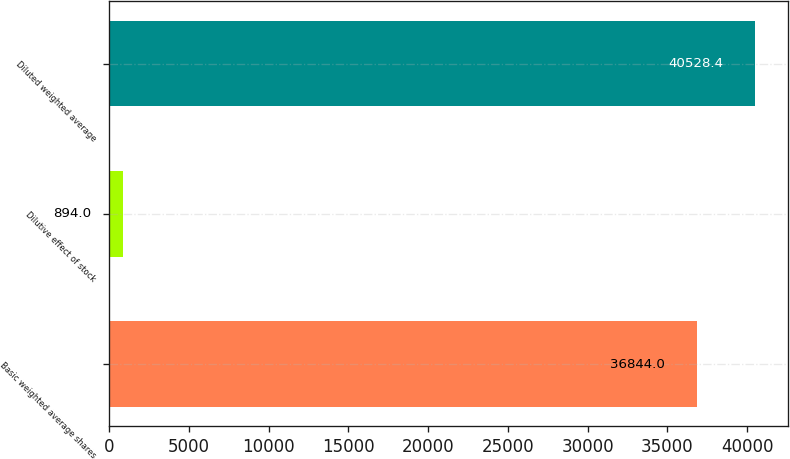<chart> <loc_0><loc_0><loc_500><loc_500><bar_chart><fcel>Basic weighted average shares<fcel>Dilutive effect of stock<fcel>Diluted weighted average<nl><fcel>36844<fcel>894<fcel>40528.4<nl></chart> 